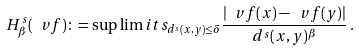<formula> <loc_0><loc_0><loc_500><loc_500>H ^ { s } _ { \beta } ( \ v f ) \colon = \sup \lim i t s _ { d ^ { s } ( x , y ) \leq \delta } \frac { | \ v f ( x ) - \ v f ( y ) | } { d ^ { s } ( x , y ) ^ { \beta } } \, .</formula> 